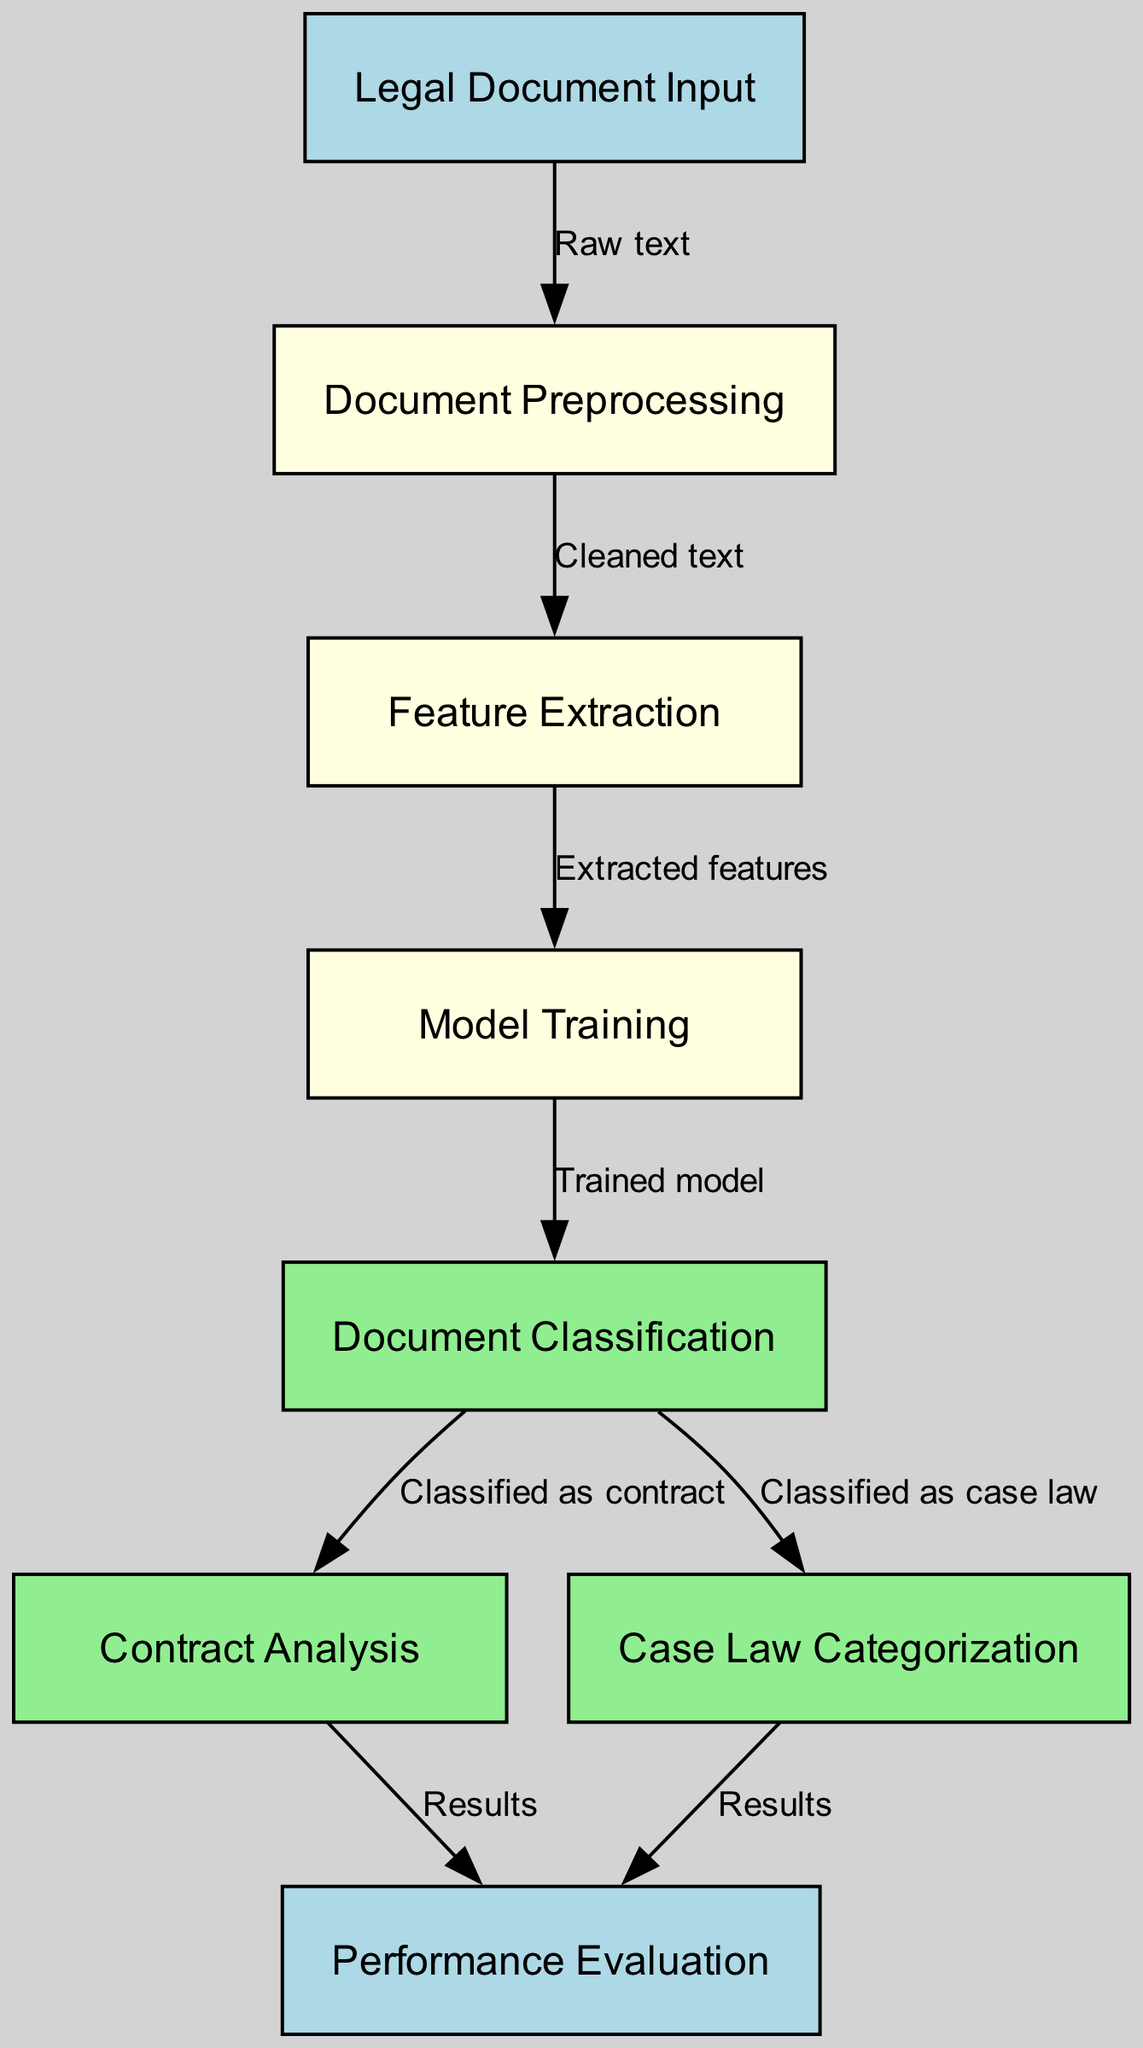What is the first step in the machine learning process shown in the diagram? The first step, represented by the node labeled "Legal Document Input," indicates that the process begins with the input of legal documents. This is the initial stage before any processing occurs.
Answer: Legal Document Input How many nodes are present in the diagram? By counting the individual nodes listed in the data, we find that there are a total of eight nodes representing different stages in the machine learning process.
Answer: Eight What output follows the "Document Classification" node? According to the edges of the diagram, the "Document Classification" node leads to two outputs: "Contract Analysis" and "Case Law Categorization," indicating that the classification can result in either of these paths.
Answer: Contract Analysis and Case Law Categorization What type of data is used to move from "Legal Document Input" to "Document Preprocessing"? The edge connecting these two nodes specifies that the data used to transition from "Legal Document Input" to "Document Preprocessing" is labeled as "Raw text," indicating that the original unprocessed text is the input.
Answer: Raw text Which nodes are directly linked to the "Performance Evaluation" node? The "Performance Evaluation" node is linked to two other nodes: "Contract Analysis" and "Case Law Categorization." Both connections represent the results from classifying documents, flowing into the performance evaluation stage.
Answer: Contract Analysis and Case Law Categorization 